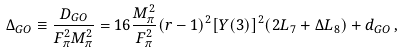Convert formula to latex. <formula><loc_0><loc_0><loc_500><loc_500>\Delta _ { G O } \equiv \frac { D _ { G O } } { F ^ { 2 } _ { \pi } M ^ { 2 } _ { \pi } } = 1 6 \frac { M ^ { 2 } _ { \pi } } { F ^ { 2 } _ { \pi } } ( r - 1 ) ^ { 2 } [ Y ( 3 ) ] ^ { 2 } ( 2 L _ { 7 } + \Delta L _ { 8 } ) + d _ { G O } \, ,</formula> 